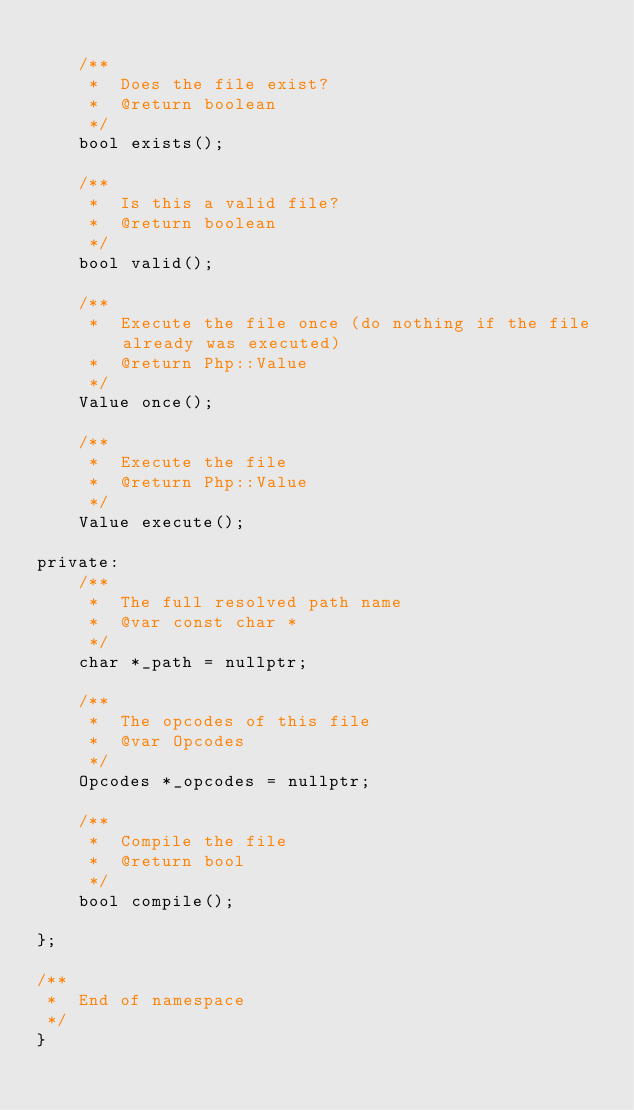Convert code to text. <code><loc_0><loc_0><loc_500><loc_500><_C_>
    /**
     *  Does the file exist?
     *  @return boolean
     */
    bool exists();

    /**
     *  Is this a valid file?
     *  @return boolean
     */
    bool valid();

    /**
     *  Execute the file once (do nothing if the file already was executed)
     *  @return Php::Value
     */
    Value once();

    /**
     *  Execute the file
     *  @return Php::Value
     */
    Value execute();

private:
    /**
     *  The full resolved path name
     *  @var const char *
     */
    char *_path = nullptr;

    /**
     *  The opcodes of this file
     *  @var Opcodes
     */
    Opcodes *_opcodes = nullptr;

    /**
     *  Compile the file
     *  @return bool
     */
    bool compile();

};

/**
 *  End of namespace
 */
}
</code> 